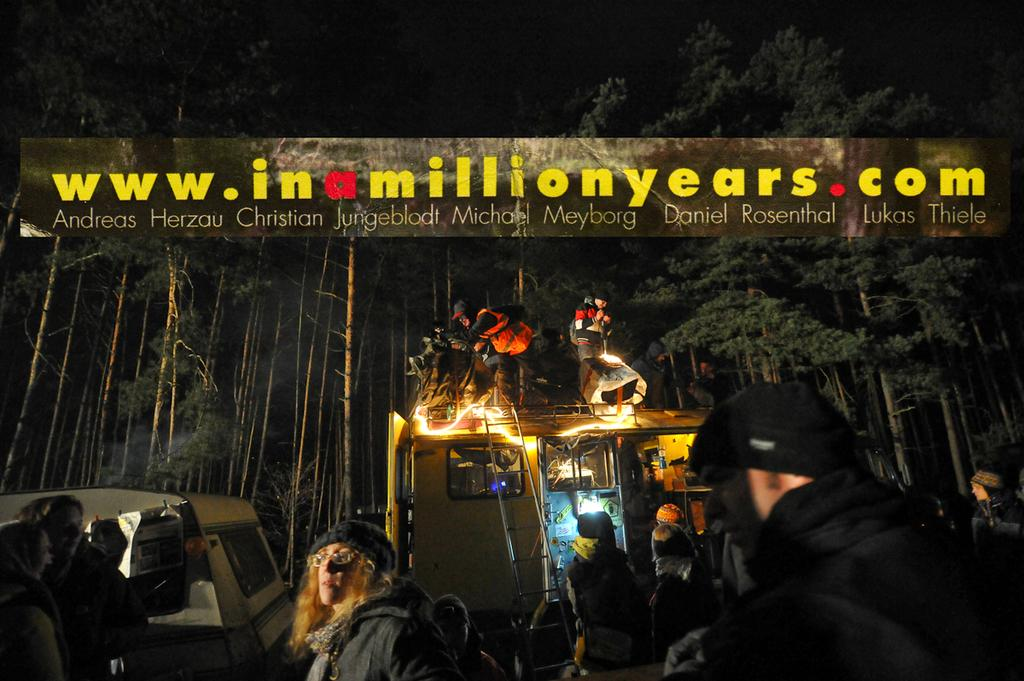Who or what is present in the image? There are people and vehicles in the image. What else can be seen in the image besides people and vehicles? There are trees in the image. Can you describe any digital elements in the image? Yes, there is a website visible in the image. Are there any words or letters visible in the image? Yes, there is some text visible in the image. Where is the bee located in the image? There is no bee present in the image. What type of leaf can be seen on the front of the vehicle? There is no leaf visible on the front of any vehicle in the image. 